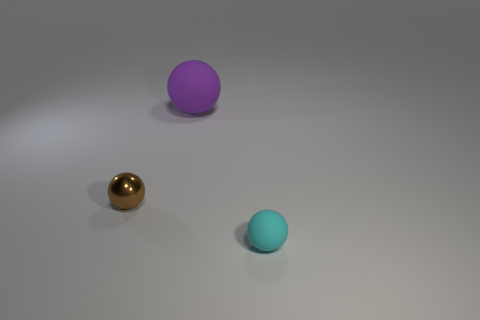Subtract all purple balls. How many balls are left? 2 Add 3 tiny cyan matte blocks. How many objects exist? 6 Subtract all brown spheres. How many spheres are left? 2 Subtract all yellow blocks. How many purple spheres are left? 1 Subtract all tiny brown balls. Subtract all purple matte things. How many objects are left? 1 Add 2 large spheres. How many large spheres are left? 3 Add 2 big blue metal cylinders. How many big blue metal cylinders exist? 2 Subtract 0 blue spheres. How many objects are left? 3 Subtract all green spheres. Subtract all cyan cubes. How many spheres are left? 3 